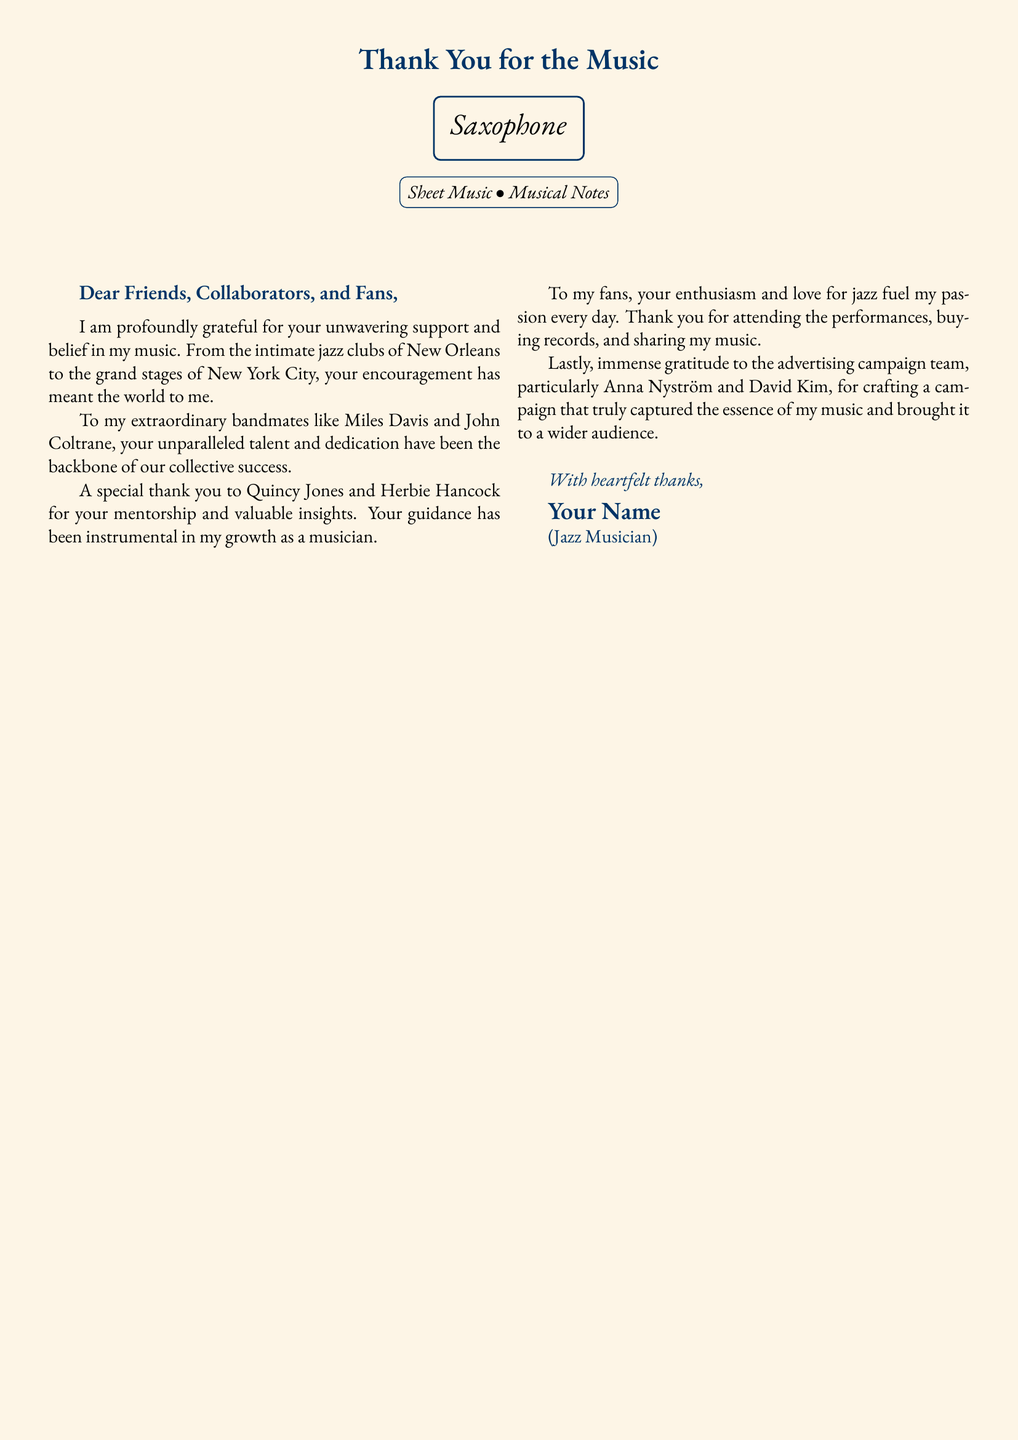What is the title of the card? The title of the card is prominently displayed at the top, stating "Thank You for the Music."
Answer: Thank You for the Music What musical instrument is illustrated on the card? The card features an illustration of a saxophone, highlighted under the title.
Answer: Saxophone Who are the bandmates mentioned in the note? The personal note mentions two bandmates by name: Miles Davis and John Coltrane, recognizing their talent and dedication.
Answer: Miles Davis and John Coltrane Which two individuals are acknowledged for their mentorship? The note specifically mentions Quincy Jones and Herbie Hancock as mentors who provided valuable insights.
Answer: Quincy Jones and Herbie Hancock What role did Anna Nyström and David Kim play? The card expresses gratitude to Anna Nyström and David Kim for their involvement in the advertising campaign that promoted the musician's work.
Answer: Advertising campaign team How is the overall tone of the card described? The tone of the card can be inferred from the language used throughout, reflecting profound gratitude and appreciation.
Answer: Grateful What does the personal note address? The personal note addresses friends, collaborators, and fans, recognizing their support and encouragement.
Answer: Friends, Collaborators, and Fans What is the theme of the card? The theme centers around expressing appreciation for the support received throughout the musician's career, particularly in relation to music.
Answer: Appreciation for support 